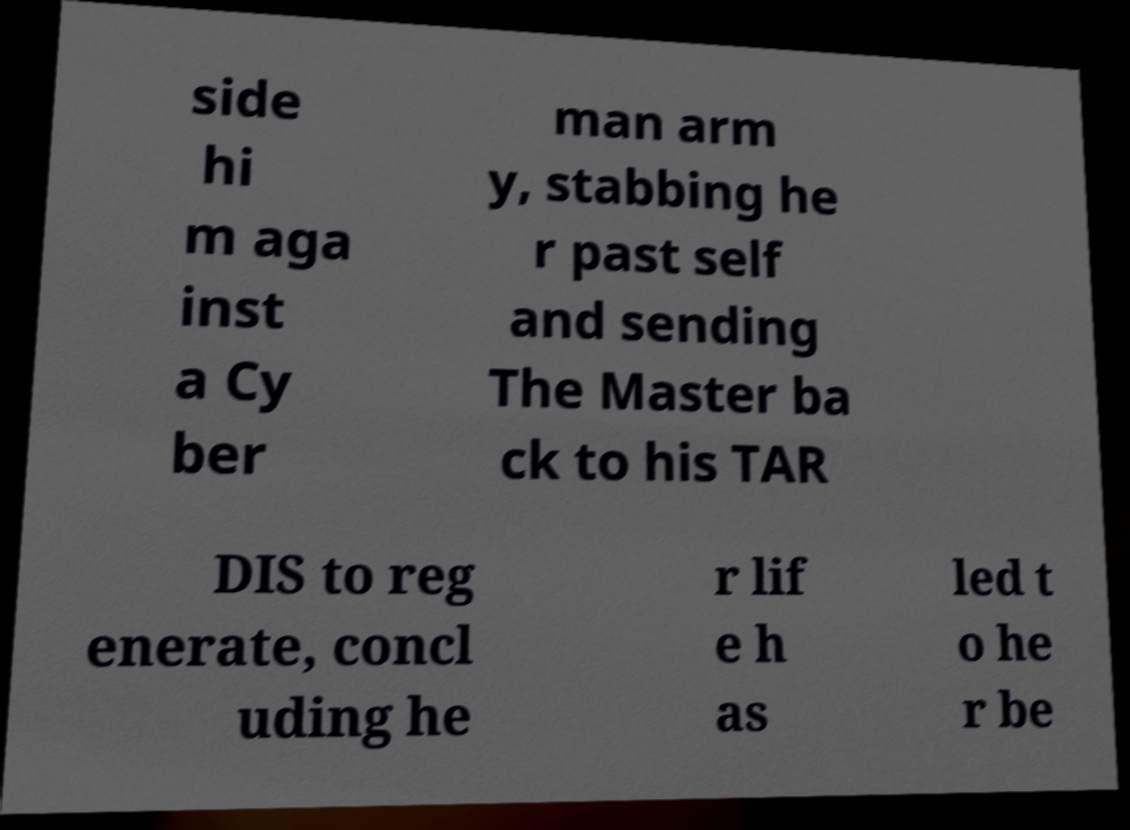Can you accurately transcribe the text from the provided image for me? side hi m aga inst a Cy ber man arm y, stabbing he r past self and sending The Master ba ck to his TAR DIS to reg enerate, concl uding he r lif e h as led t o he r be 